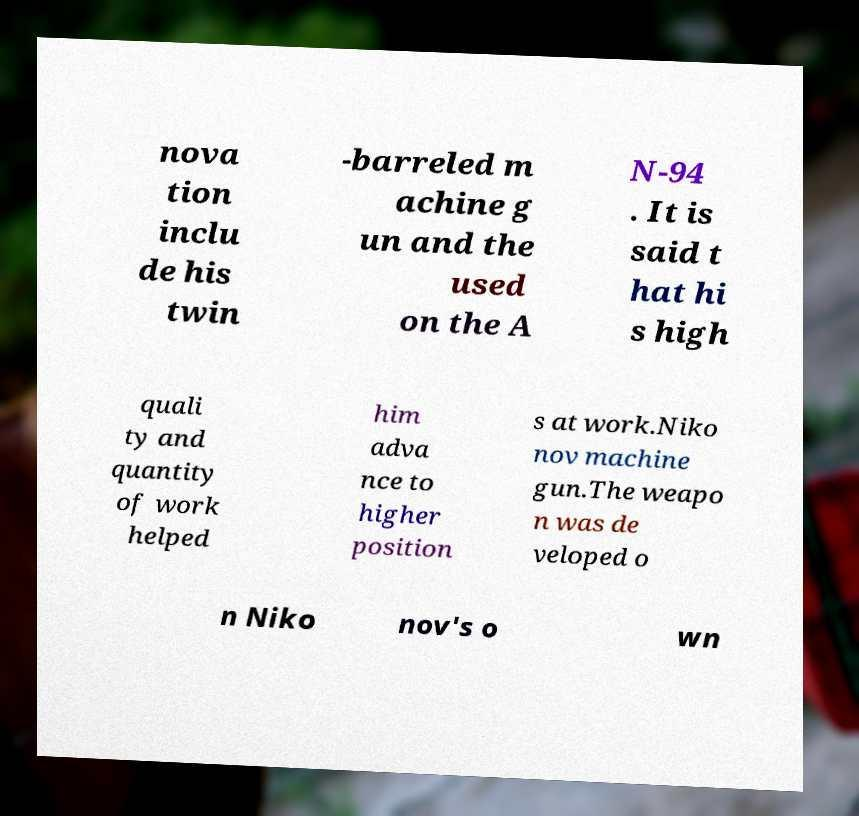I need the written content from this picture converted into text. Can you do that? nova tion inclu de his twin -barreled m achine g un and the used on the A N-94 . It is said t hat hi s high quali ty and quantity of work helped him adva nce to higher position s at work.Niko nov machine gun.The weapo n was de veloped o n Niko nov's o wn 